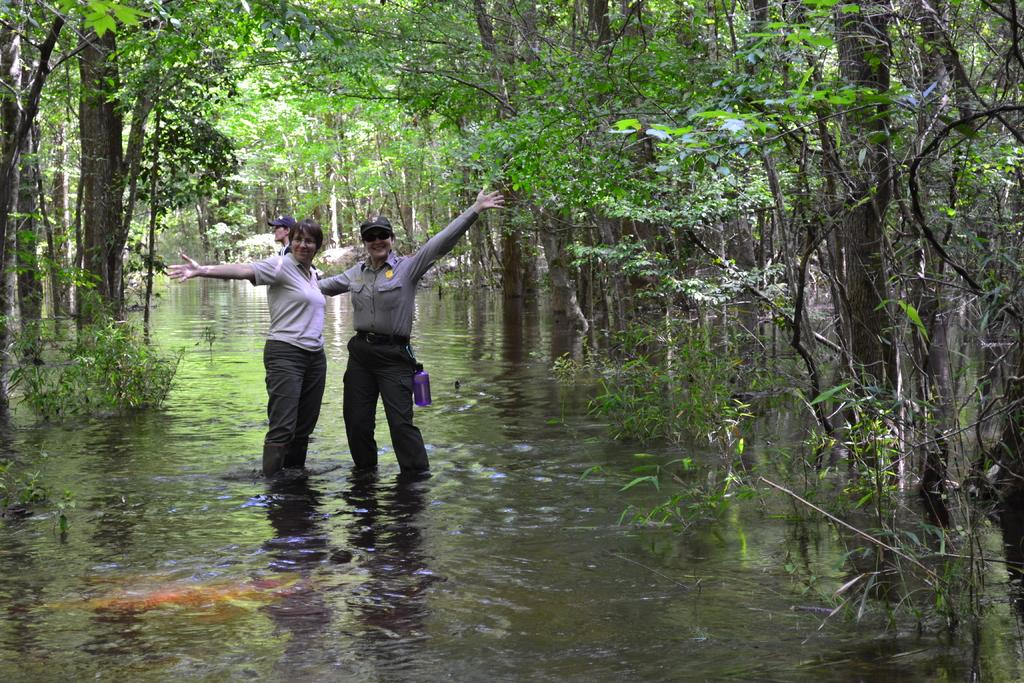How many people are in the water in the image? There are three people standing in the water in the image. What can be seen in the background of the image? There are many trees in the background of the image. What type of yarn is being used by the people in the water? There is no yarn present in the image; the people are simply standing in the water. 